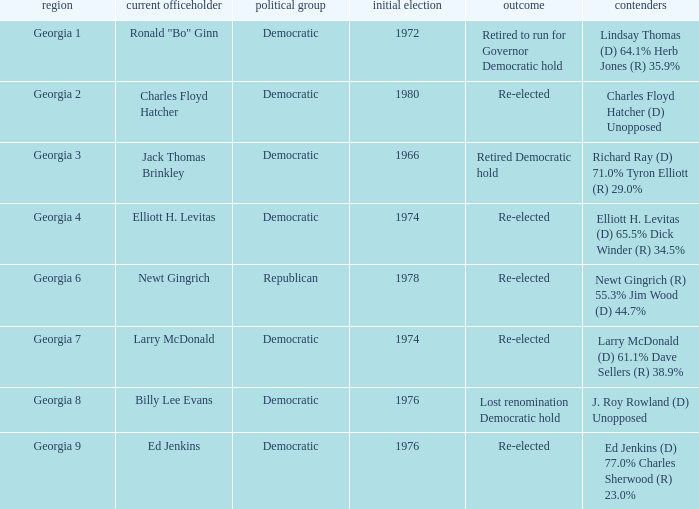Name the candidates for georgia 8 J. Roy Rowland (D) Unopposed. 